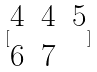<formula> <loc_0><loc_0><loc_500><loc_500>[ \begin{matrix} 4 & 4 & 5 \\ 6 & 7 \end{matrix} ]</formula> 